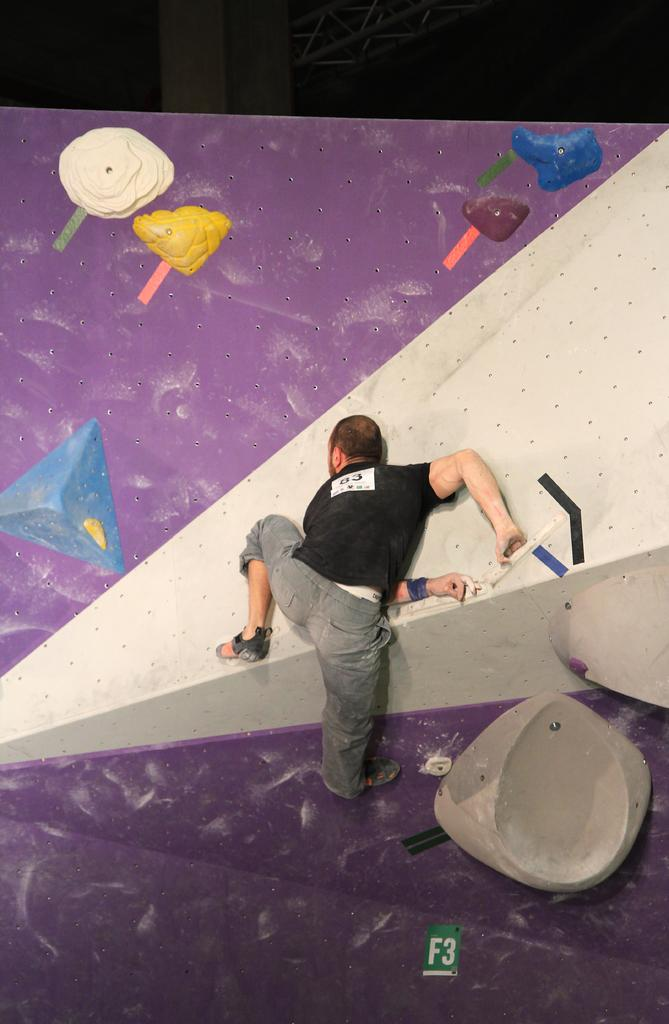What is the person in the image doing? The person is standing and painting. What is the person painting on? There is a painting on a board. What can be seen in the background of the image? There is a pillar and a pole in the background of the image. How does the person compare the heat of the receipt to the painting in the image? There is no receipt present in the image, and therefore no comparison can be made between the heat of a receipt and the painting. 